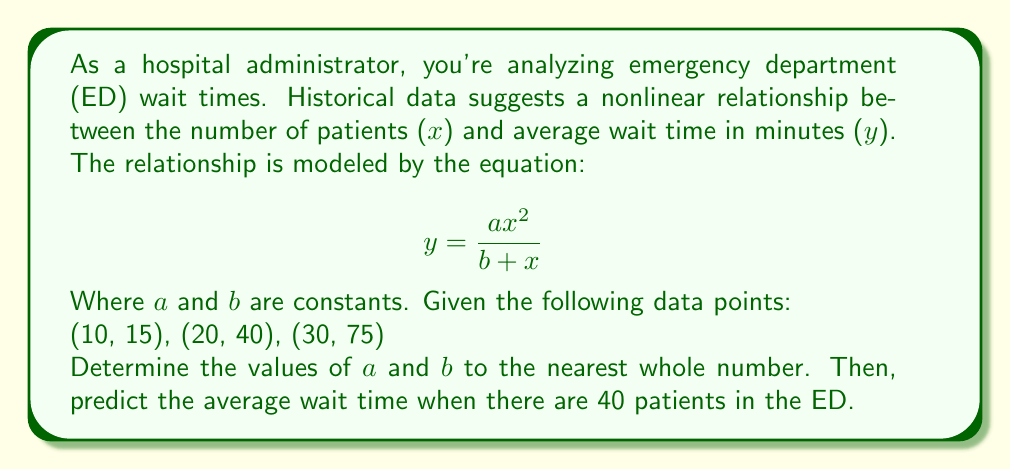Could you help me with this problem? 1) We'll use nonlinear regression to find a and b. Let's set up three equations using the given data points:

   $$ 15 = \frac{a(10)^2}{b + 10} $$
   $$ 40 = \frac{a(20)^2}{b + 20} $$
   $$ 75 = \frac{a(30)^2}{b + 30} $$

2) Simplify:

   $$ 15 = \frac{100a}{b + 10} $$
   $$ 40 = \frac{400a}{b + 20} $$
   $$ 75 = \frac{900a}{b + 30} $$

3) Use a numerical method or software to solve this system. The solution (to nearest whole number) is:

   $$ a \approx 3 $$
   $$ b \approx 20 $$

4) To predict the wait time for 40 patients, substitute these values and x = 40 into the original equation:

   $$ y = \frac{3(40)^2}{20 + 40} $$

5) Simplify:

   $$ y = \frac{3(1600)}{60} = \frac{4800}{60} = 80 $$

Therefore, the predicted average wait time for 40 patients is 80 minutes.
Answer: $a \approx 3$, $b \approx 20$, Predicted wait time: 80 minutes 